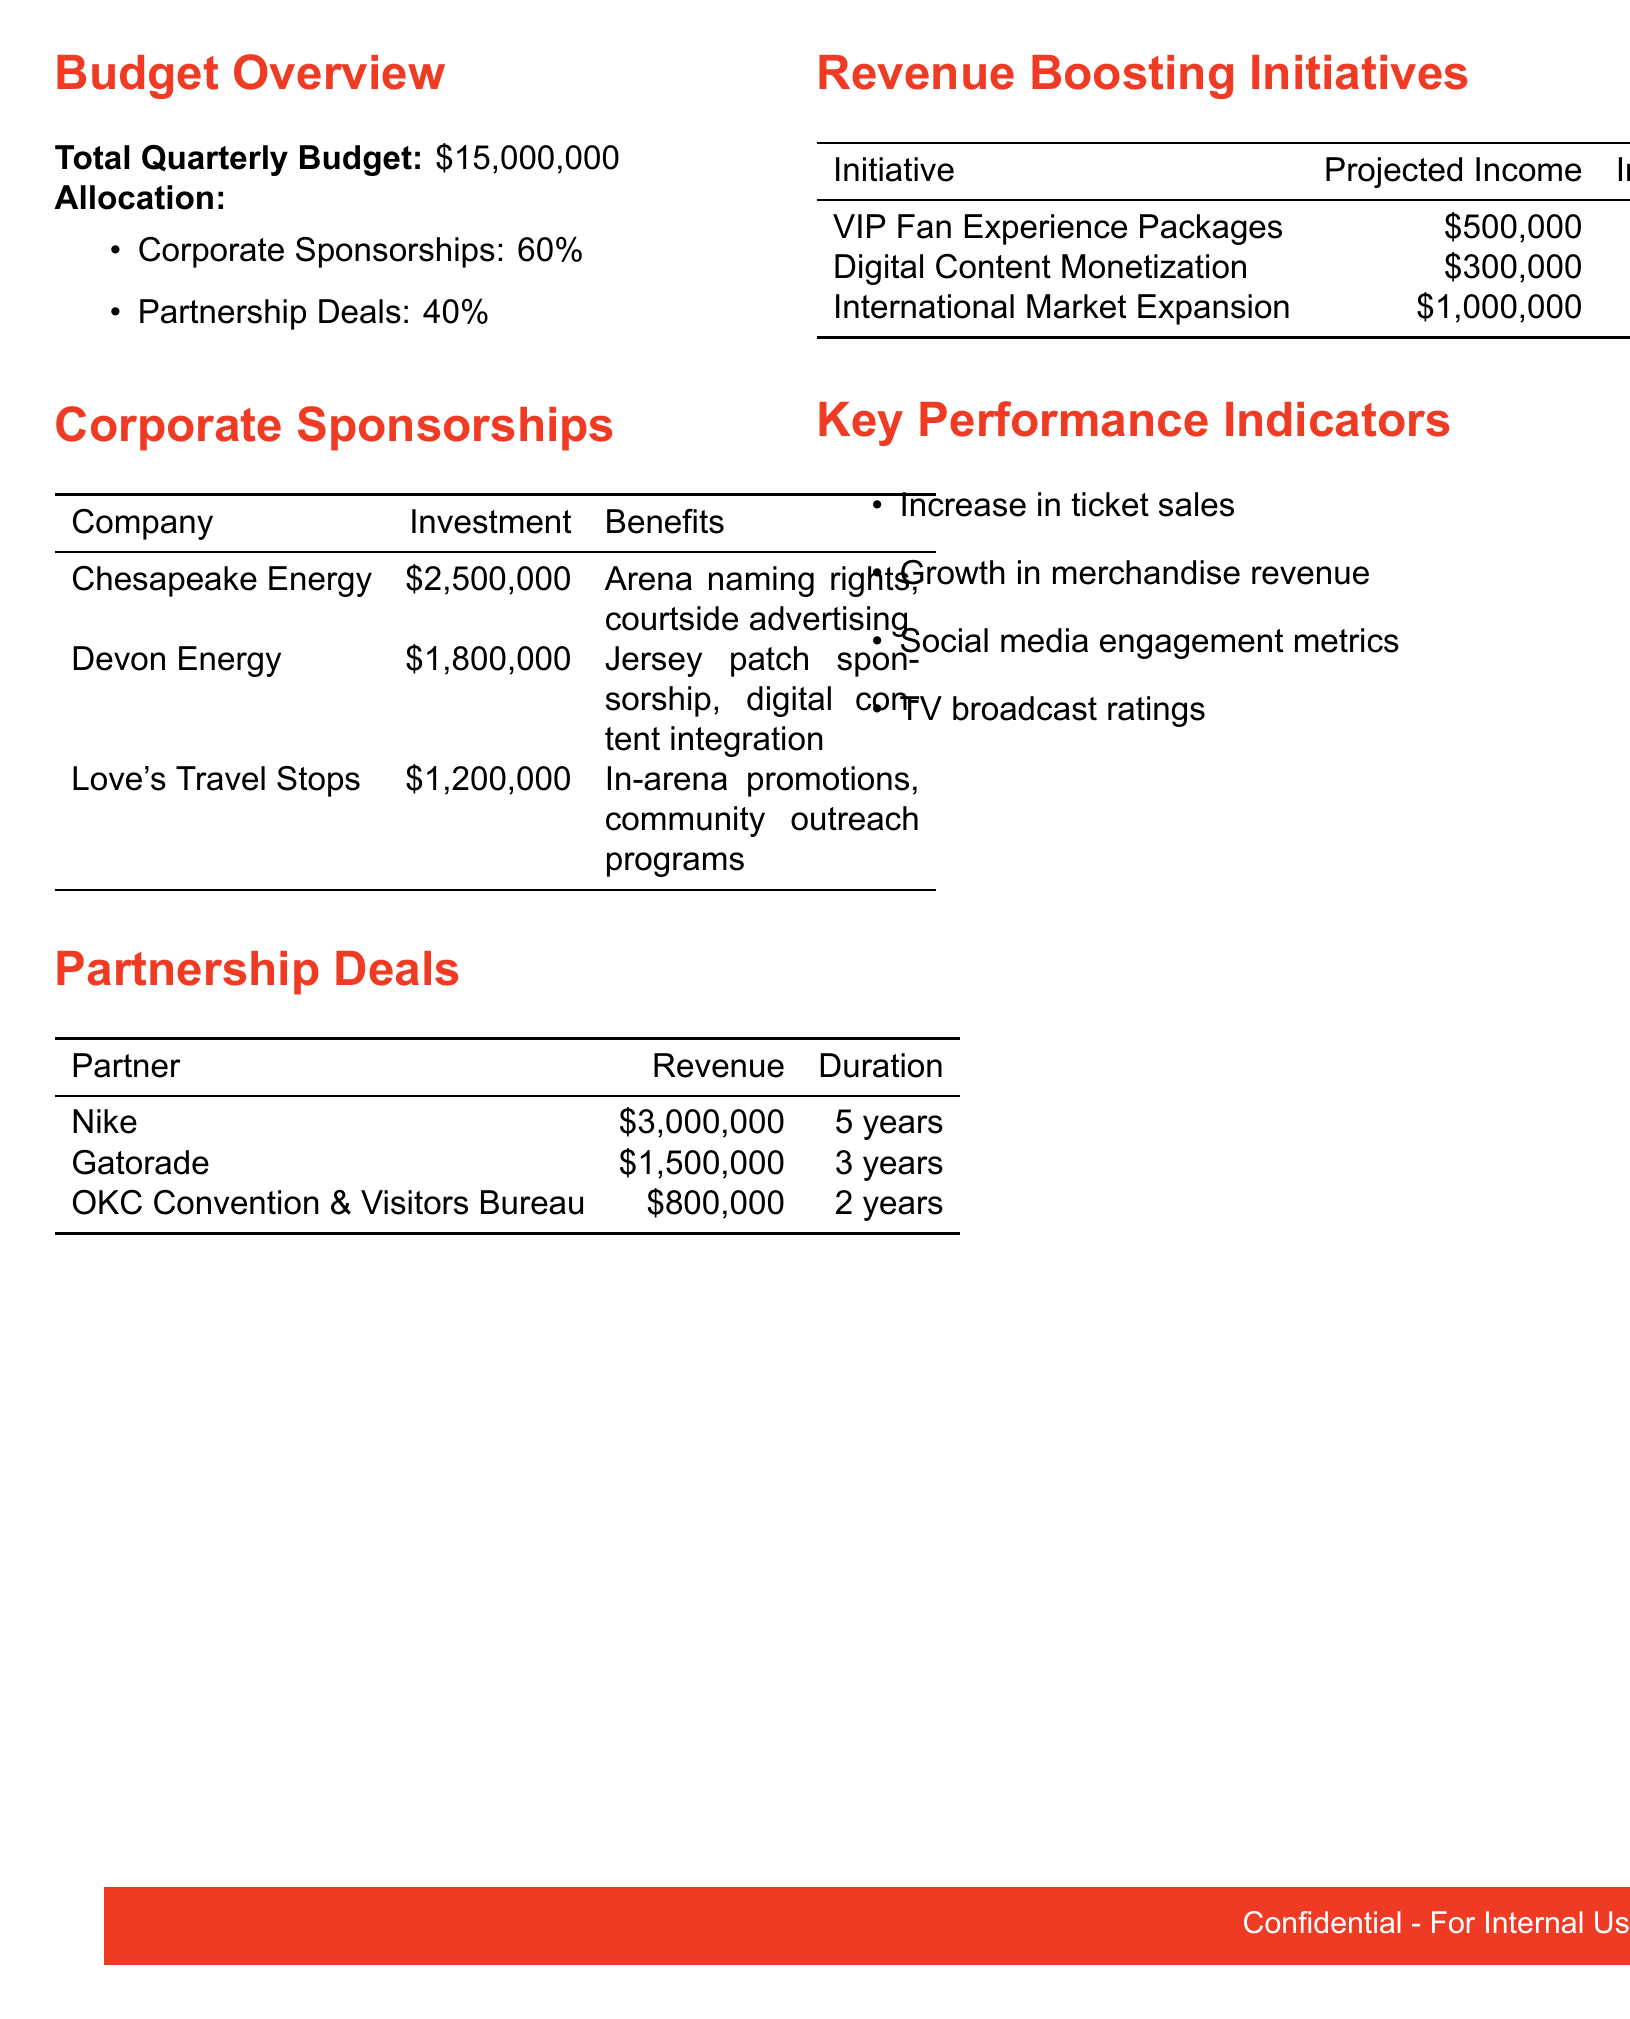What is the total quarterly budget? The total quarterly budget is specified at the top of the budget overview section.
Answer: $15,000,000 What percentage is allocated to corporate sponsorships? The allocation for corporate sponsorships is mentioned in the budget overview section.
Answer: 60% Who is the partner that has a revenue of $3,000,000? The revenue for partners is listed in the partnership deals section, which identifies the partner associated with this amount.
Answer: Nike What is the projected income from the International Market Expansion initiative? The projected income for each revenue-boosting initiative is detailed in its respective table.
Answer: $1,000,000 How much does Devon Energy invest? The investment amounts for each corporate sponsorship are included in the corporate sponsorships table.
Answer: $1,800,000 What is the duration of the partnership with Gatorade? The duration for each partnership deal is provided in the partnership deals section of the document.
Answer: 3 years What benefits does Love's Travel Stops receive? The specific benefits for each corporate sponsorship are listed next to the corresponding company.
Answer: In-arena promotions, community outreach programs What is the implementation cost for Digital Content Monetization? The implementation cost of each revenue-boosting initiative is outlined in the respective table.
Answer: $100,000 What KPIs are included in the document? The key performance indicators are outlined as bullet points that highlight the focus areas for measuring success.
Answer: Increase in ticket sales, growth in merchandise revenue, social media engagement metrics, TV broadcast ratings 